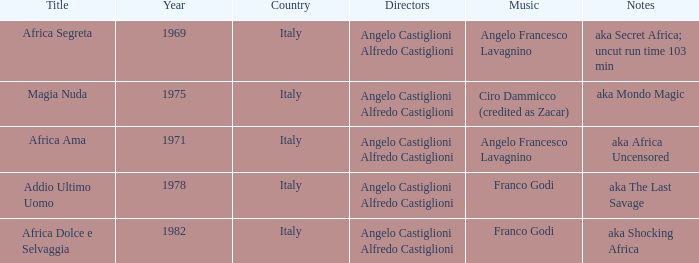Could you parse the entire table as a dict? {'header': ['Title', 'Year', 'Country', 'Directors', 'Music', 'Notes'], 'rows': [['Africa Segreta', '1969', 'Italy', 'Angelo Castiglioni Alfredo Castiglioni', 'Angelo Francesco Lavagnino', 'aka Secret Africa; uncut run time 103 min'], ['Magia Nuda', '1975', 'Italy', 'Angelo Castiglioni Alfredo Castiglioni', 'Ciro Dammicco (credited as Zacar)', 'aka Mondo Magic'], ['Africa Ama', '1971', 'Italy', 'Angelo Castiglioni Alfredo Castiglioni', 'Angelo Francesco Lavagnino', 'aka Africa Uncensored'], ['Addio Ultimo Uomo', '1978', 'Italy', 'Angelo Castiglioni Alfredo Castiglioni', 'Franco Godi', 'aka The Last Savage'], ['Africa Dolce e Selvaggia', '1982', 'Italy', 'Angelo Castiglioni Alfredo Castiglioni', 'Franco Godi', 'aka Shocking Africa']]} How many years have a Title of Magia Nuda? 1.0. 